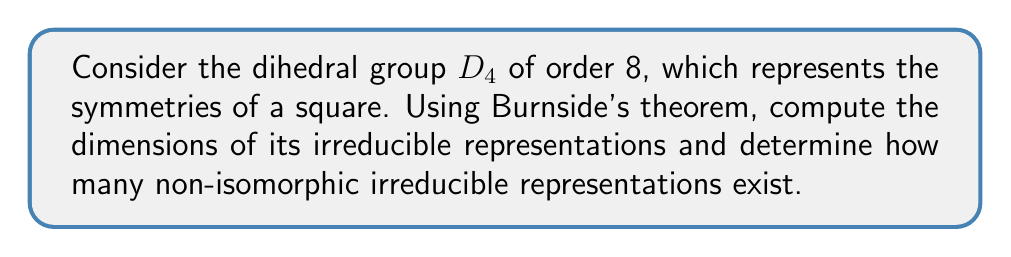Can you solve this math problem? Let's approach this step-by-step:

1) Recall Burnside's theorem: For a finite group $G$, the sum of the squares of the dimensions of its irreducible representations is equal to the order of the group. Mathematically,

   $$\sum_{i=1}^k d_i^2 = |G|$$

   where $d_i$ are the dimensions of the irreducible representations and $k$ is the number of non-isomorphic irreducible representations.

2) For $D_4$, we know that $|G| = 8$.

3) To find the dimensions, we need to consider the conjugacy classes of $D_4$. $D_4$ has 5 conjugacy classes:
   - $\{e\}$ (identity)
   - $\{r^2\}$ (180° rotation)
   - $\{r, r^3\}$ (90° rotations)
   - $\{s, sr^2\}$ (reflections across diagonals)
   - $\{sr, sr^3\}$ (reflections across midlines)

4) The number of conjugacy classes equals the number of irreducible representations. So, $k = 5$.

5) We know that for any group, there is always a 1-dimensional trivial representation. Let's call it $d_1 = 1$.

6) Given the structure of $D_4$, we can deduce that there are three more 1-dimensional representations (corresponding to the three non-trivial linear characters of $D_4/D_4' \cong C_2 \times C_2$). So, $d_2 = d_3 = d_4 = 1$.

7) Let the dimension of the remaining representation be $d_5 = x$.

8) Applying Burnside's theorem:

   $$1^2 + 1^2 + 1^2 + 1^2 + x^2 = 8$$

9) Simplifying:

   $$4 + x^2 = 8$$
   $$x^2 = 4$$
   $$x = 2$$

Therefore, $D_4$ has four 1-dimensional irreducible representations and one 2-dimensional irreducible representation.
Answer: $d_1 = d_2 = d_3 = d_4 = 1$, $d_5 = 2$; 5 non-isomorphic irreducible representations 